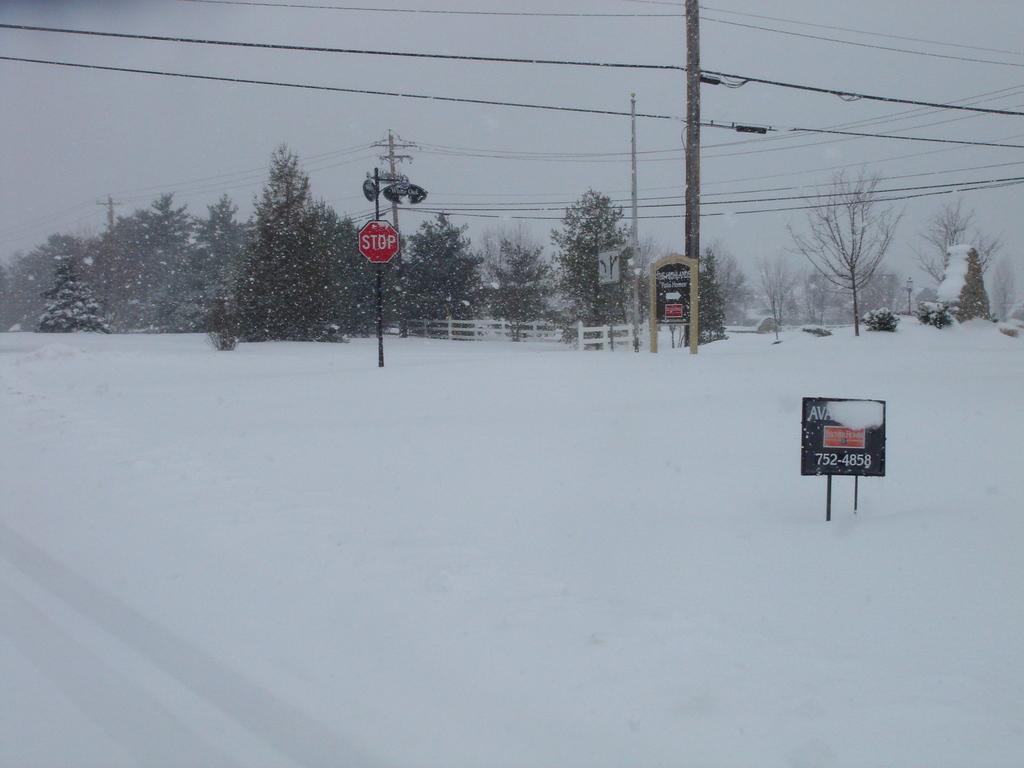In one or two sentences, can you explain what this image depicts? In the image there is caution board in the front with trees and electric poles behind on the snow land and above its sky. 